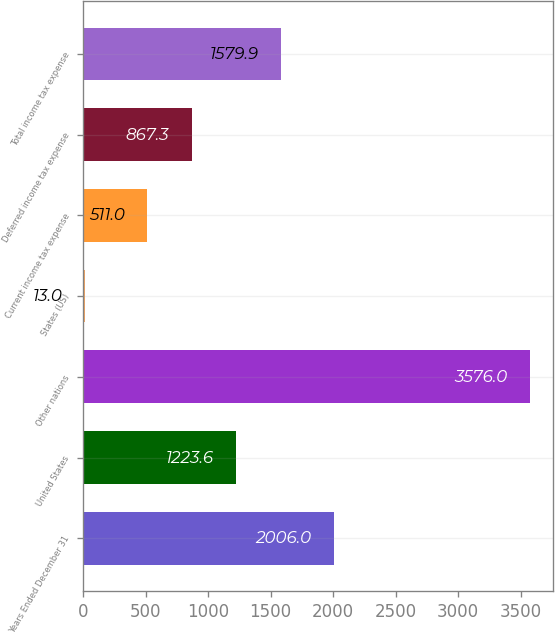Convert chart. <chart><loc_0><loc_0><loc_500><loc_500><bar_chart><fcel>Years Ended December 31<fcel>United States<fcel>Other nations<fcel>States (US)<fcel>Current income tax expense<fcel>Deferred income tax expense<fcel>Total income tax expense<nl><fcel>2006<fcel>1223.6<fcel>3576<fcel>13<fcel>511<fcel>867.3<fcel>1579.9<nl></chart> 